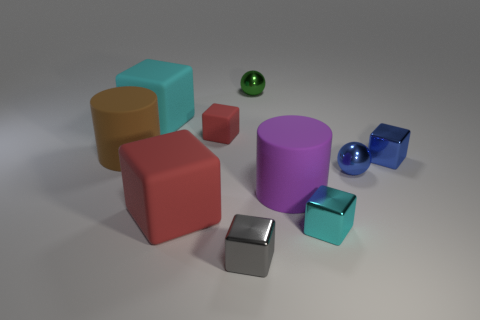Subtract all cyan blocks. How many were subtracted if there are1cyan blocks left? 1 Subtract 3 cubes. How many cubes are left? 3 Subtract all gray blocks. How many blocks are left? 5 Subtract all big cubes. How many cubes are left? 4 Subtract all brown blocks. Subtract all yellow spheres. How many blocks are left? 6 Subtract all blocks. How many objects are left? 4 Subtract 0 gray balls. How many objects are left? 10 Subtract all tiny gray objects. Subtract all big brown rubber things. How many objects are left? 8 Add 8 small green metal things. How many small green metal things are left? 9 Add 3 big objects. How many big objects exist? 7 